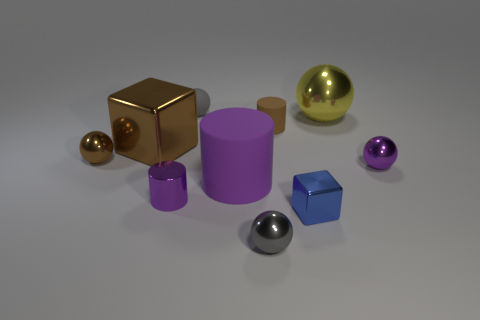Is there a tiny green thing that has the same shape as the purple matte thing?
Make the answer very short. No. What number of other things are the same shape as the tiny brown matte thing?
Your answer should be compact. 2. Is the shape of the small brown shiny thing the same as the tiny purple object that is to the right of the tiny brown matte cylinder?
Your answer should be very brief. Yes. Is there any other thing that is made of the same material as the purple sphere?
Provide a succinct answer. Yes. There is a big brown thing that is the same shape as the small blue metal thing; what is its material?
Your answer should be very brief. Metal. How many tiny things are brown balls or purple shiny balls?
Provide a succinct answer. 2. Are there fewer tiny things that are behind the tiny brown metal ball than purple shiny things that are on the right side of the large ball?
Your response must be concise. No. How many things are small gray objects or blue cylinders?
Offer a very short reply. 2. There is a large purple thing; how many tiny metallic balls are in front of it?
Your answer should be compact. 1. Does the big matte thing have the same color as the metal cylinder?
Make the answer very short. Yes. 